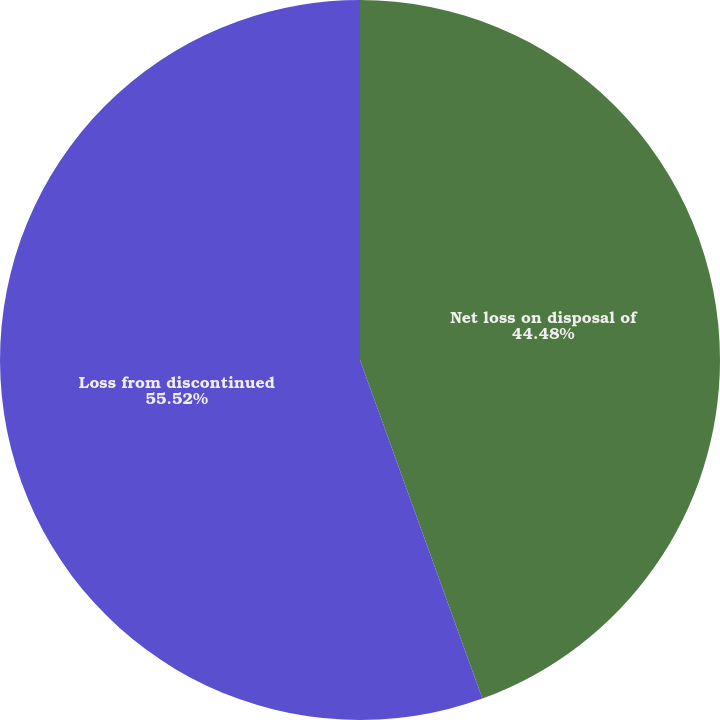Convert chart. <chart><loc_0><loc_0><loc_500><loc_500><pie_chart><fcel>Net loss on disposal of<fcel>Loss from discontinued<nl><fcel>44.48%<fcel>55.52%<nl></chart> 